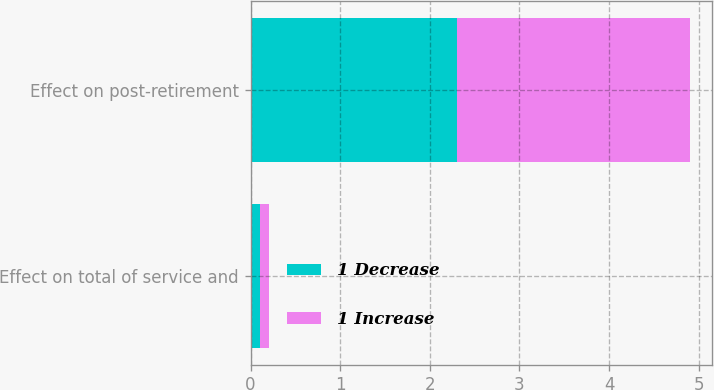<chart> <loc_0><loc_0><loc_500><loc_500><stacked_bar_chart><ecel><fcel>Effect on total of service and<fcel>Effect on post-retirement<nl><fcel>1 Decrease<fcel>0.1<fcel>2.3<nl><fcel>1 Increase<fcel>0.1<fcel>2.6<nl></chart> 